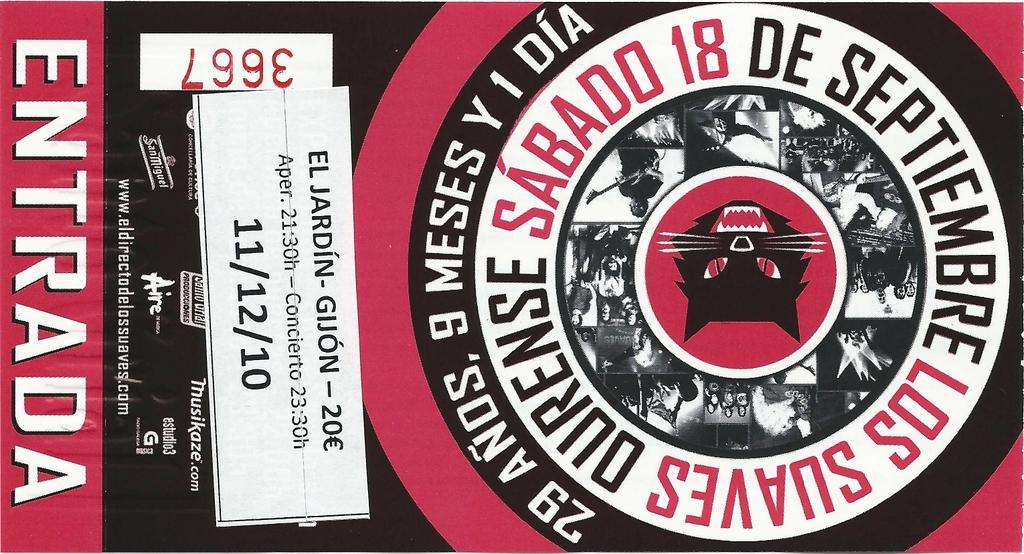<image>
Offer a succinct explanation of the picture presented. Ticket for sabado los suaves for november two thousand ten 